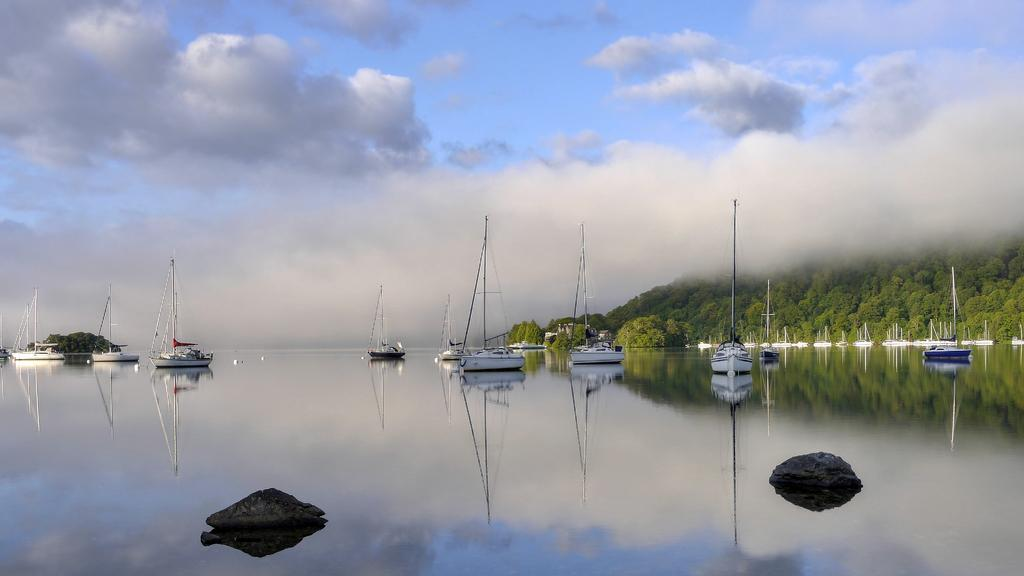What is the main feature of the image? The main feature of the image is a water surface. What can be seen on the water surface? There are ships on the water surface. What objects are present in the front of the image? There are two rocks in the front of the image. What type of vegetation is on the right side of the image? There are many trees on the right side of the image. What kind of trouble is the grandfather experiencing in the image? There is no grandfather or any indication of trouble in the image. 